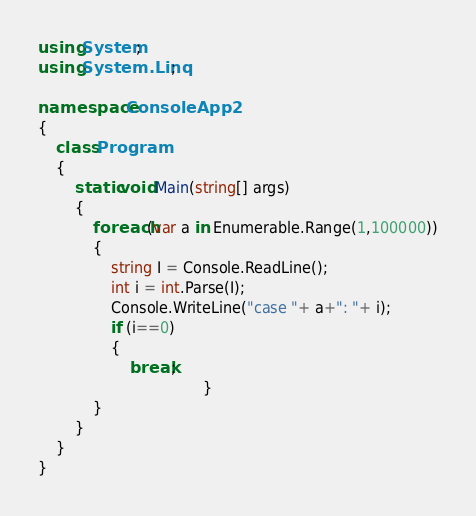Convert code to text. <code><loc_0><loc_0><loc_500><loc_500><_C#_>using System;
using System.Linq;

namespace ConsoleApp2
{
    class Program
    {
        static void Main(string[] args)
        {
            foreach(var a in Enumerable.Range(1,100000))
            {
                string I = Console.ReadLine();
                int i = int.Parse(I);
                Console.WriteLine("case "+ a+": "+ i);
                if (i==0)
                {
                    break;
                                    }
            }
        }
    }
}</code> 